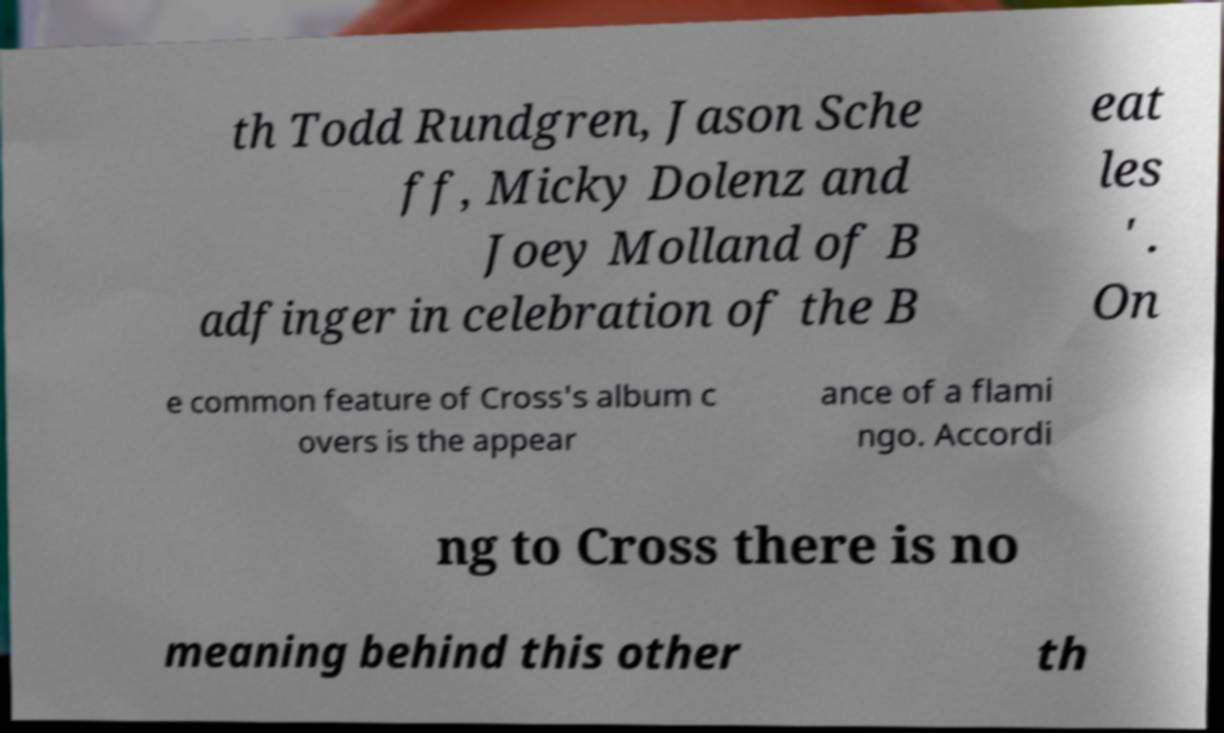There's text embedded in this image that I need extracted. Can you transcribe it verbatim? th Todd Rundgren, Jason Sche ff, Micky Dolenz and Joey Molland of B adfinger in celebration of the B eat les ' . On e common feature of Cross's album c overs is the appear ance of a flami ngo. Accordi ng to Cross there is no meaning behind this other th 